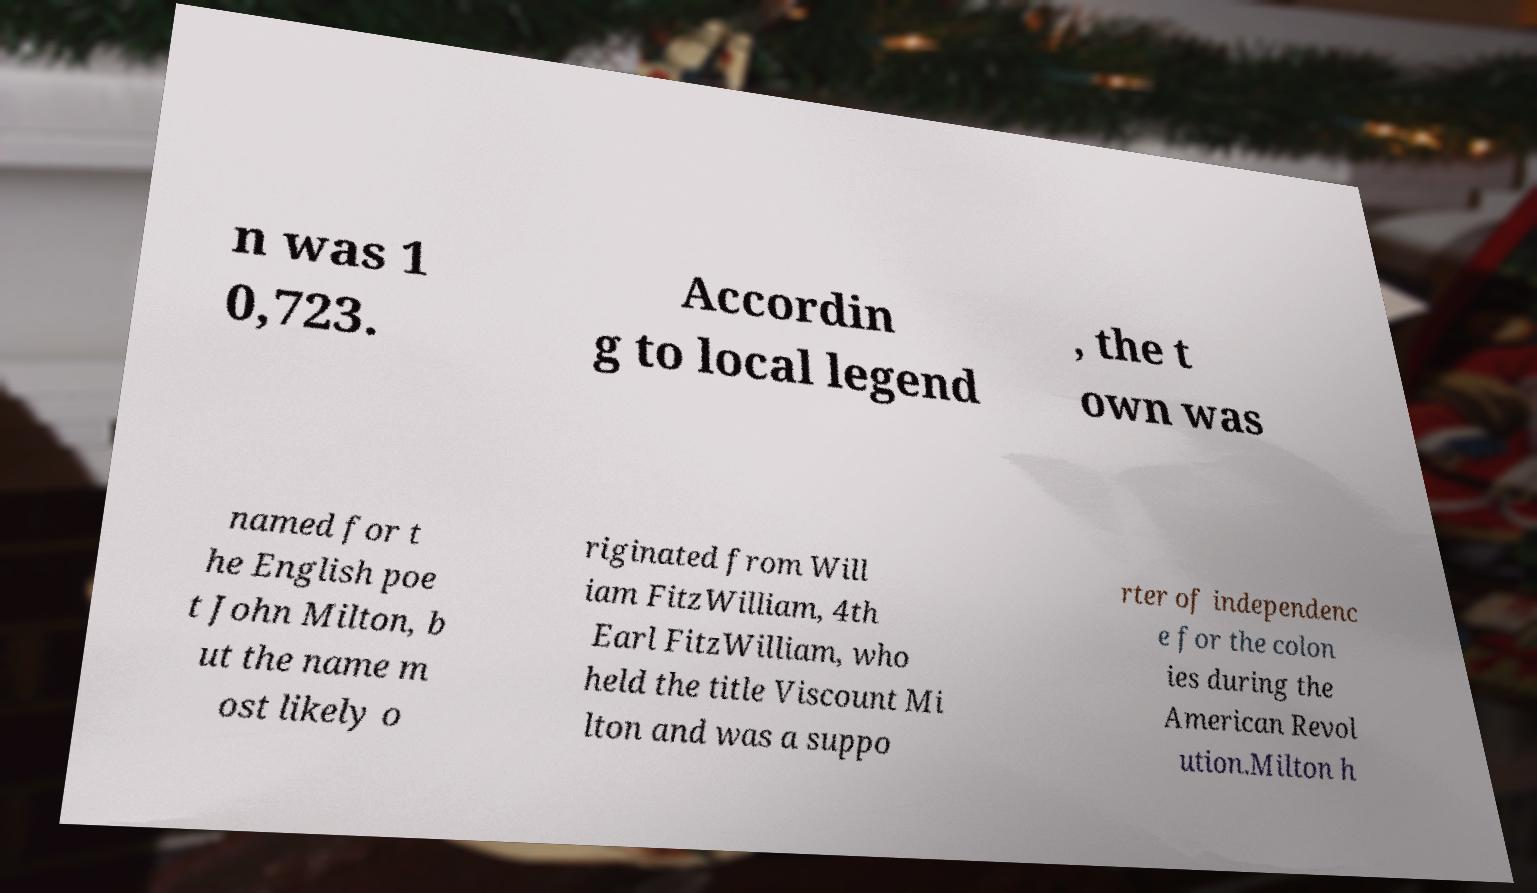Can you accurately transcribe the text from the provided image for me? n was 1 0,723. Accordin g to local legend , the t own was named for t he English poe t John Milton, b ut the name m ost likely o riginated from Will iam FitzWilliam, 4th Earl FitzWilliam, who held the title Viscount Mi lton and was a suppo rter of independenc e for the colon ies during the American Revol ution.Milton h 